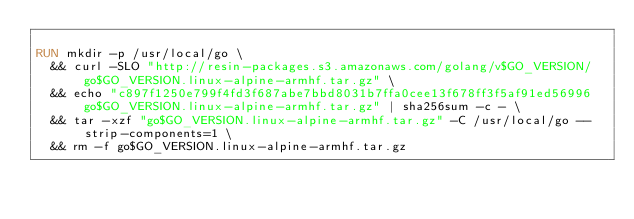Convert code to text. <code><loc_0><loc_0><loc_500><loc_500><_Dockerfile_>
RUN mkdir -p /usr/local/go \
	&& curl -SLO "http://resin-packages.s3.amazonaws.com/golang/v$GO_VERSION/go$GO_VERSION.linux-alpine-armhf.tar.gz" \
	&& echo "c897f1250e799f4fd3f687abe7bbd8031b7ffa0cee13f678ff3f5af91ed56996  go$GO_VERSION.linux-alpine-armhf.tar.gz" | sha256sum -c - \
	&& tar -xzf "go$GO_VERSION.linux-alpine-armhf.tar.gz" -C /usr/local/go --strip-components=1 \
	&& rm -f go$GO_VERSION.linux-alpine-armhf.tar.gz
</code> 